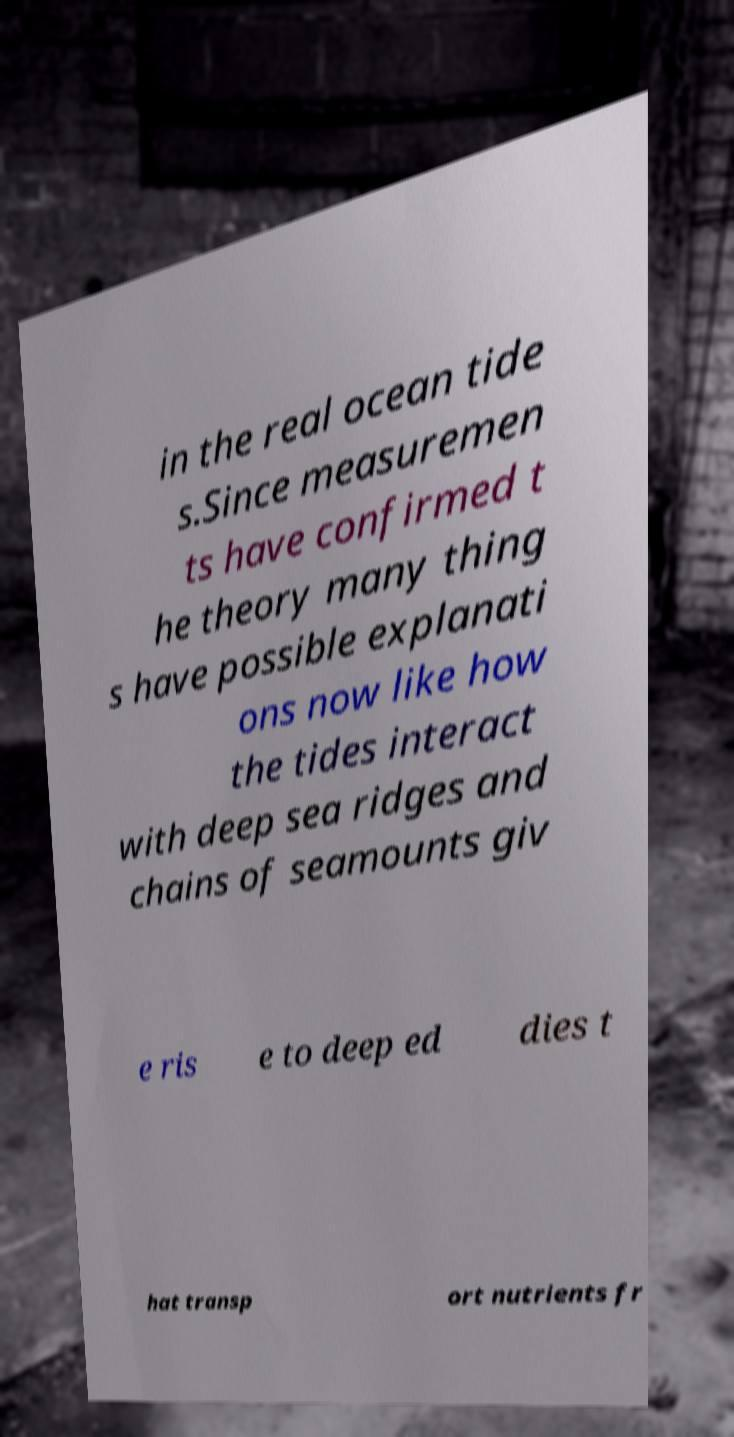Could you assist in decoding the text presented in this image and type it out clearly? in the real ocean tide s.Since measuremen ts have confirmed t he theory many thing s have possible explanati ons now like how the tides interact with deep sea ridges and chains of seamounts giv e ris e to deep ed dies t hat transp ort nutrients fr 